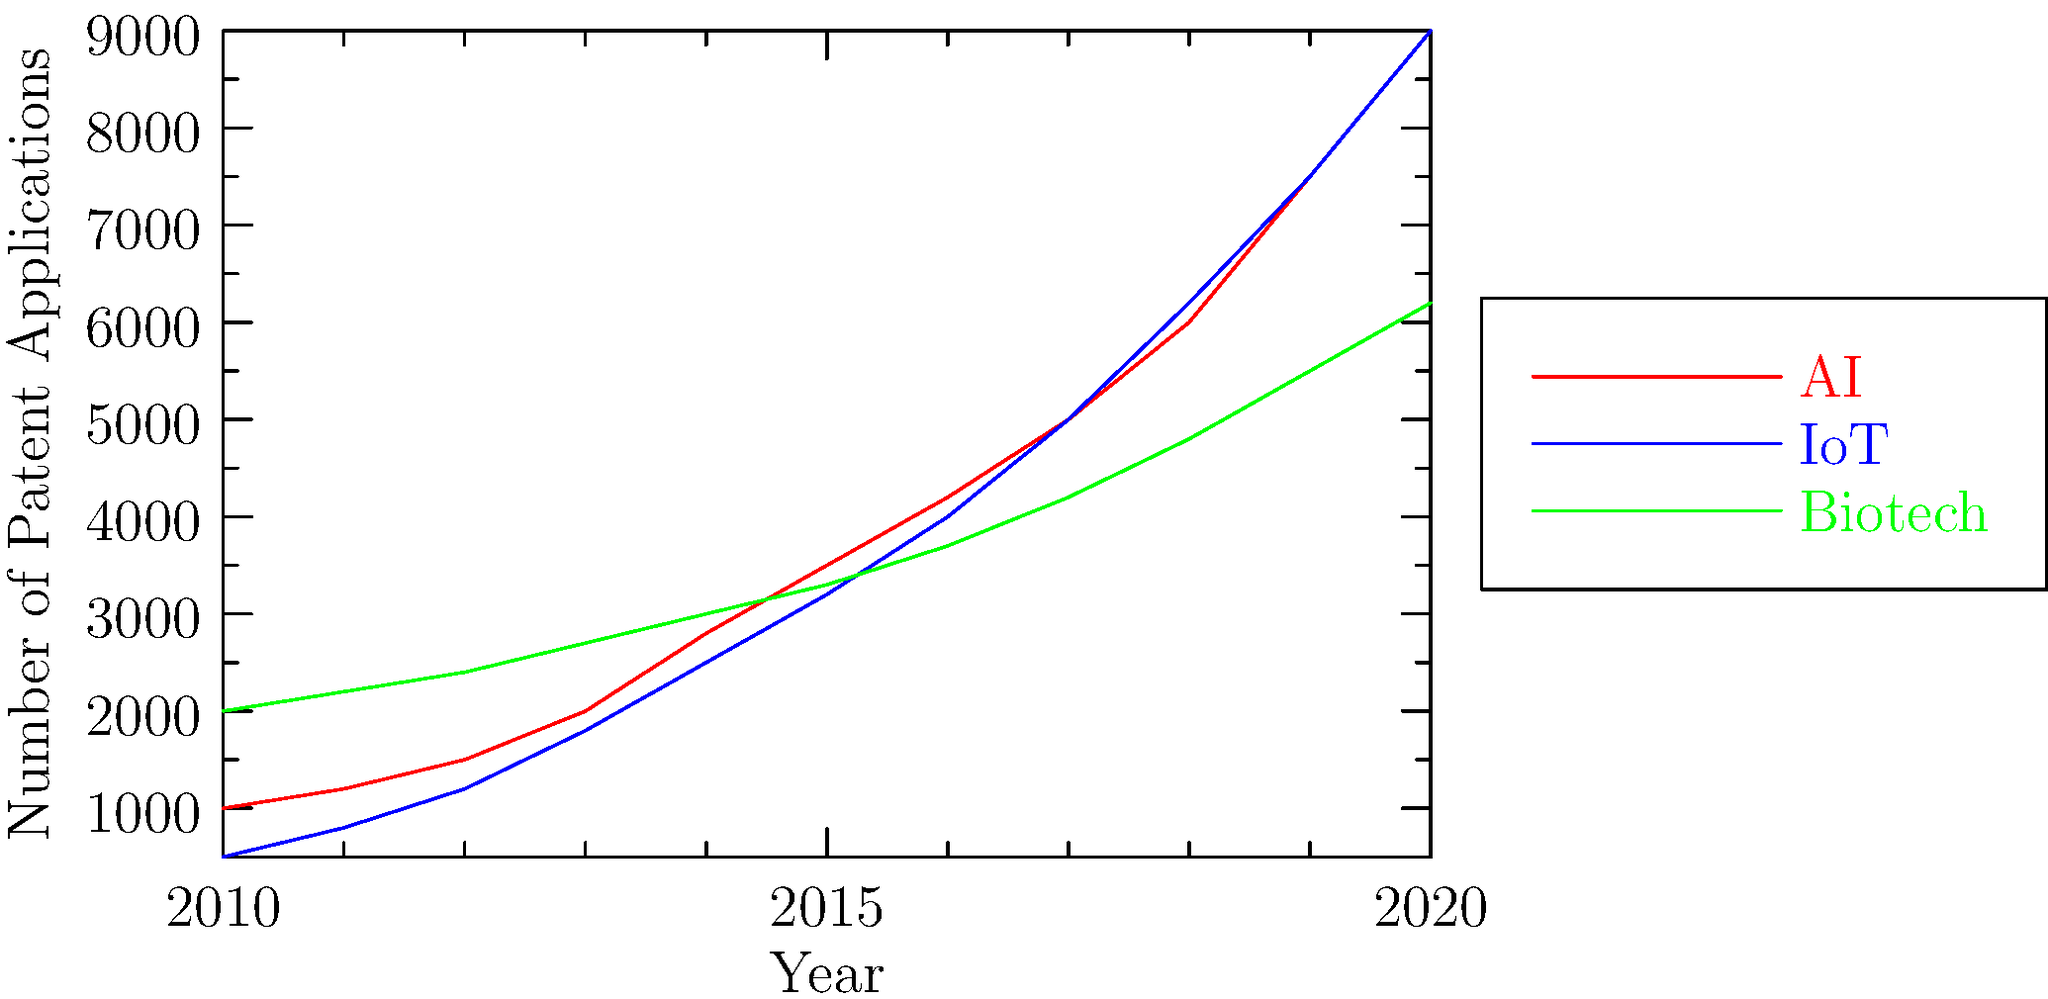Based on the multi-line graph showing patent application trends in different technological fields from 2010 to 2020, which field experienced the most rapid growth in patent applications, and what might this suggest about the industry's development? To determine which field experienced the most rapid growth in patent applications, we need to analyze the slopes of the lines for each technological field:

1. Artificial Intelligence (AI) - Red line:
   - Started at about 1,000 applications in 2010
   - Ended at about 9,000 applications in 2020
   - Shows a steep, exponential-like growth curve

2. Internet of Things (IoT) - Blue line:
   - Started at about 500 applications in 2010
   - Ended at about 9,000 applications in 2020
   - Also shows a steep, exponential-like growth curve

3. Biotechnology - Green line:
   - Started at about 2,000 applications in 2010
   - Ended at about 6,200 applications in 2020
   - Shows a more gradual, linear growth

Comparing the growth rates:
- AI increased by approximately 8,000 applications over the decade
- IoT increased by approximately 8,500 applications over the decade
- Biotech increased by approximately 4,200 applications over the decade

The IoT field shows the steepest growth, closely followed by AI. Both fields demonstrate exponential growth patterns, indicating rapid technological advancements and increasing interest from inventors and companies.

This rapid growth in IoT and AI patent applications suggests:
1. Increased investment in these technologies
2. Rapid innovation and development of new applications
3. Growing market demand for IoT and AI solutions
4. Potential for these fields to become dominant in the technology sector
5. Increased competition among companies to secure intellectual property rights in these areas

The relatively slower growth in Biotechnology applications might indicate a more mature or regulated industry, with steady but less explosive innovation compared to IoT and AI.
Answer: Internet of Things (IoT), suggesting rapid technological advancement and increasing market interest in connected devices and systems. 